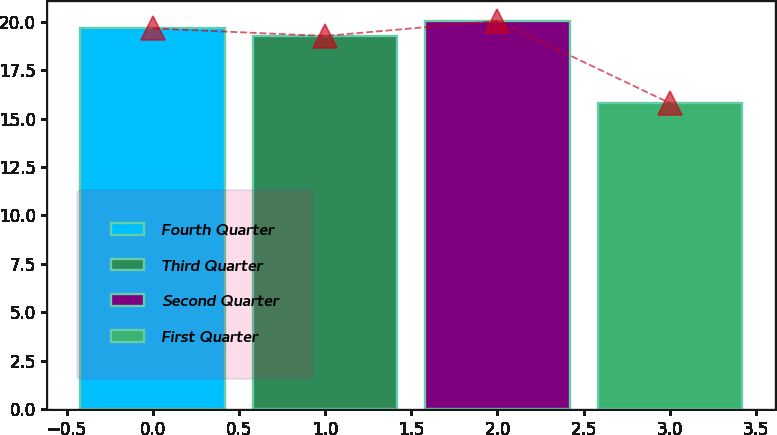<chart> <loc_0><loc_0><loc_500><loc_500><bar_chart><fcel>Fourth Quarter<fcel>Third Quarter<fcel>Second Quarter<fcel>First Quarter<nl><fcel>19.67<fcel>19.28<fcel>20.06<fcel>15.81<nl></chart> 